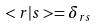Convert formula to latex. <formula><loc_0><loc_0><loc_500><loc_500>< r | s > = \delta _ { r s }</formula> 